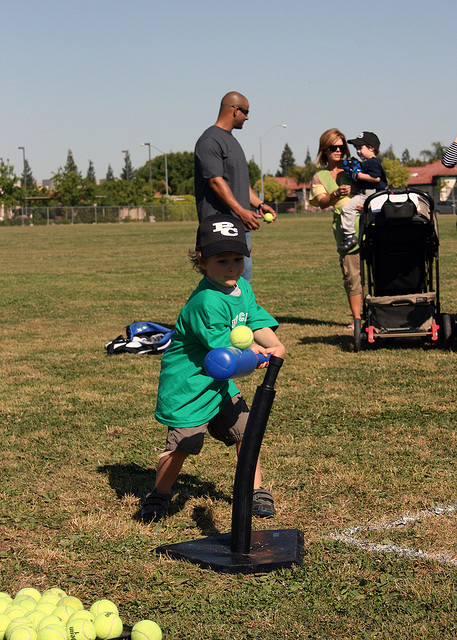Identify the text displayed in this image. PC 